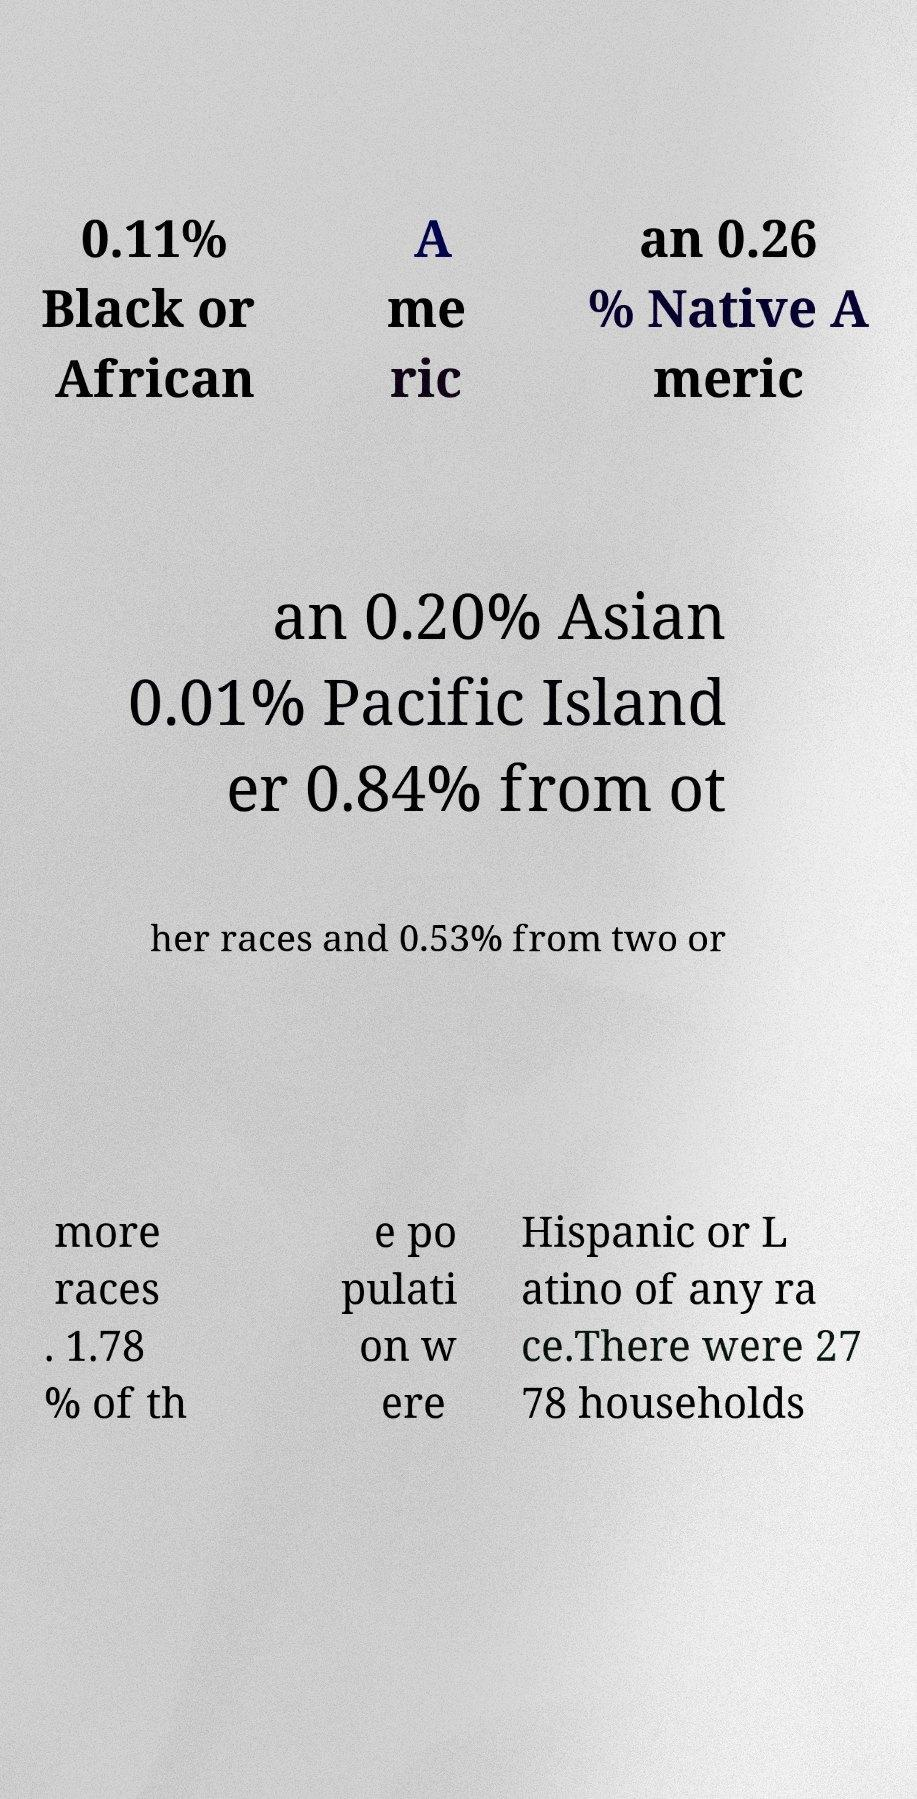Can you read and provide the text displayed in the image?This photo seems to have some interesting text. Can you extract and type it out for me? 0.11% Black or African A me ric an 0.26 % Native A meric an 0.20% Asian 0.01% Pacific Island er 0.84% from ot her races and 0.53% from two or more races . 1.78 % of th e po pulati on w ere Hispanic or L atino of any ra ce.There were 27 78 households 